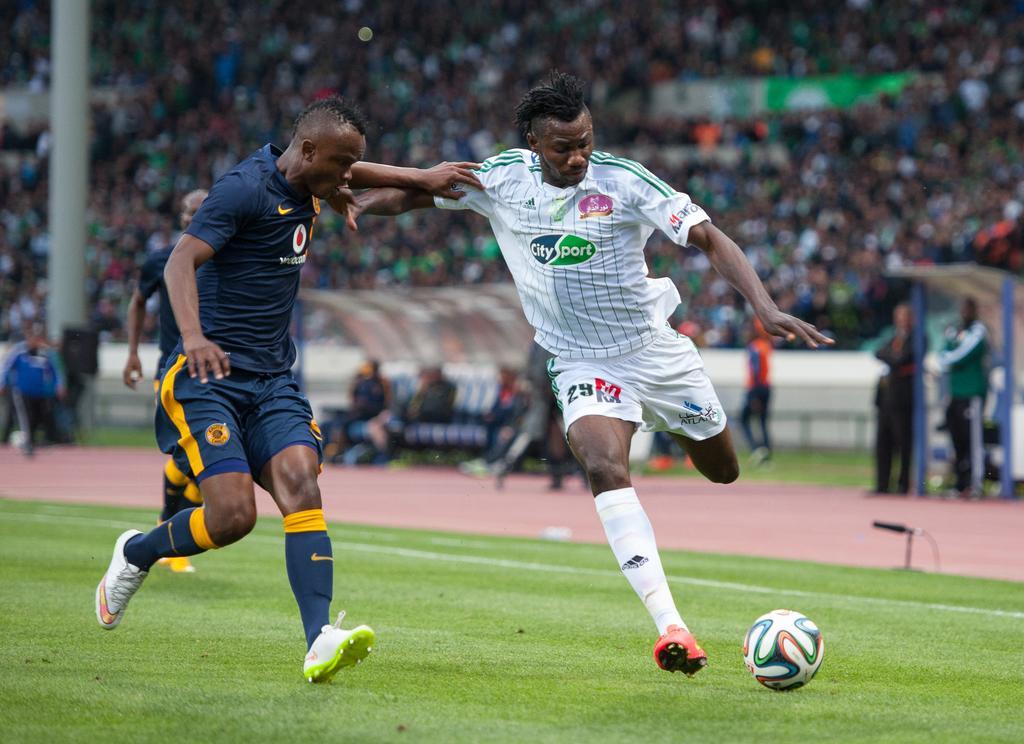Could you give a brief overview of what you see in this image? In the image there are two players running behind football on the ground and behind there are many people sitting and staring at the game. 